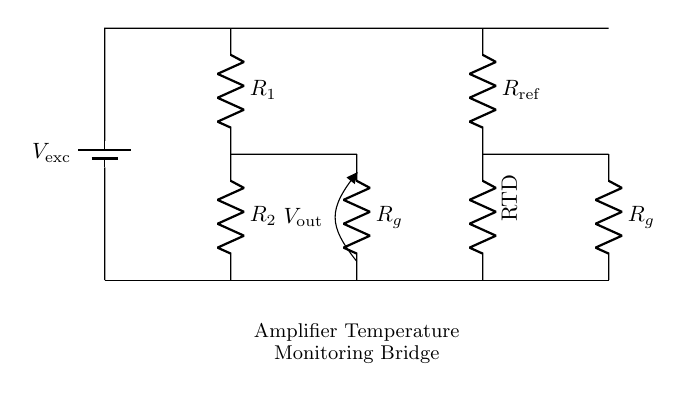What type of circuit is depicted in the diagram? This circuit is a bridge circuit, which is typically used to measure the resistance of a temperature sensor, such as an RTD. It consists of various resistors and a voltage supply.
Answer: bridge circuit What is the role of the RTD in this circuit? The RTD (Resistance Temperature Detector) measures temperature by varying its resistance with temperature change. It provides a resistance value that is part of the bridge circuit allowing for temperature monitoring.
Answer: temperature measurement What is connected in series with the RTD? The resistor labeled as R reference is connected in series with the RTD, forming part of the upper leg of the bridge with the voltage supply.
Answer: R reference What is the total number of resistors in the circuit? There are four resistors in this circuit: R1, R2, R reference, and two RG resistors, which are configured to form the bridge.
Answer: four How can you determine the output voltage of the circuit? The output voltage can be determined by analyzing the voltage divider principle applied to the bridge. The voltage out is influenced by the ratio of values of the resistors in the bridge configuration.
Answer: voltage divider principle What does V_out represent in this circuit? V_out represents the output voltage of the bridge circuit, which indicates the balance or unbalance of the bridge caused by a change in temperature affecting the RTD.
Answer: output voltage What happens when the RTD resistance changes? When the RTD resistance changes due to temperature variation, it causes an imbalance in the bridge circuit, which alters V_out that can be measured to infer temperature changes.
Answer: V_out changes 